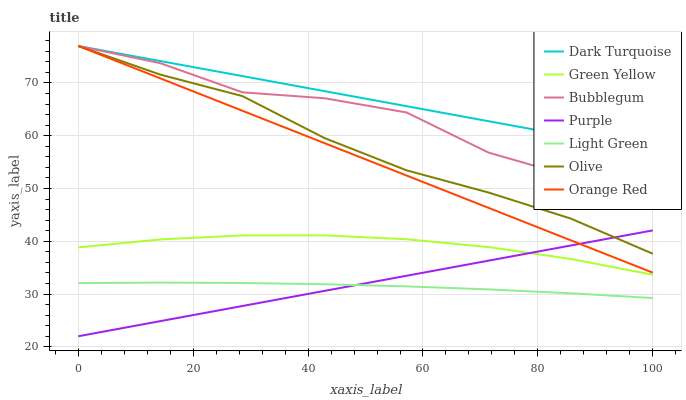Does Light Green have the minimum area under the curve?
Answer yes or no. Yes. Does Dark Turquoise have the maximum area under the curve?
Answer yes or no. Yes. Does Bubblegum have the minimum area under the curve?
Answer yes or no. No. Does Bubblegum have the maximum area under the curve?
Answer yes or no. No. Is Purple the smoothest?
Answer yes or no. Yes. Is Bubblegum the roughest?
Answer yes or no. Yes. Is Dark Turquoise the smoothest?
Answer yes or no. No. Is Dark Turquoise the roughest?
Answer yes or no. No. Does Purple have the lowest value?
Answer yes or no. Yes. Does Bubblegum have the lowest value?
Answer yes or no. No. Does Orange Red have the highest value?
Answer yes or no. Yes. Does Light Green have the highest value?
Answer yes or no. No. Is Light Green less than Orange Red?
Answer yes or no. Yes. Is Bubblegum greater than Green Yellow?
Answer yes or no. Yes. Does Bubblegum intersect Orange Red?
Answer yes or no. Yes. Is Bubblegum less than Orange Red?
Answer yes or no. No. Is Bubblegum greater than Orange Red?
Answer yes or no. No. Does Light Green intersect Orange Red?
Answer yes or no. No. 